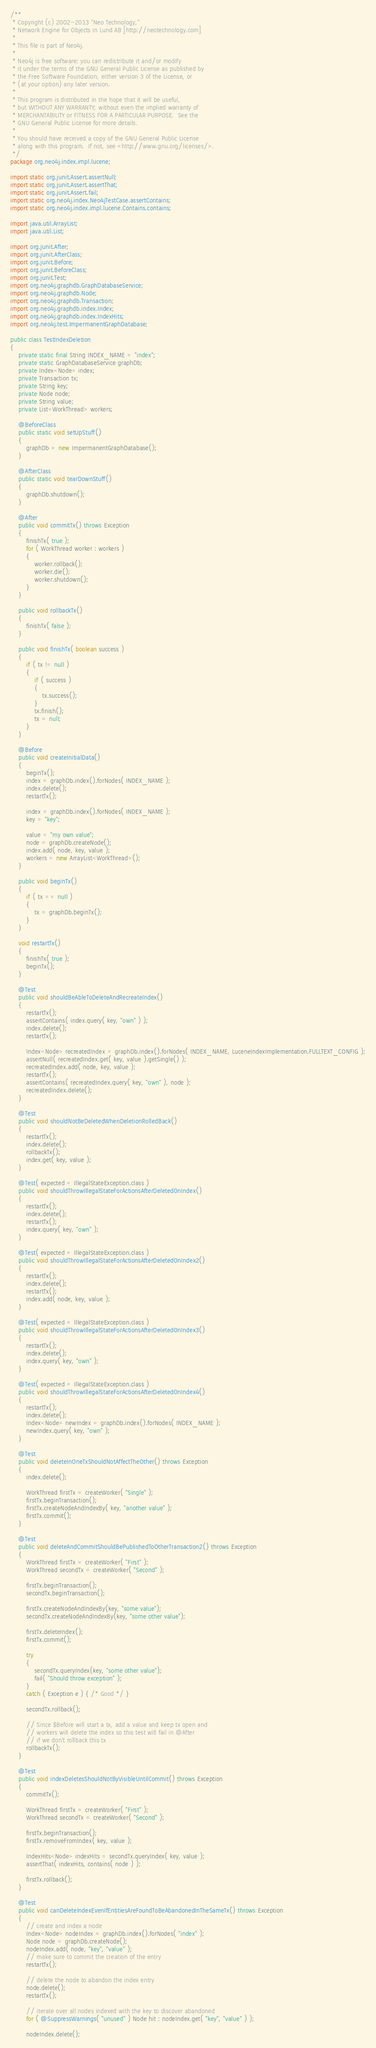<code> <loc_0><loc_0><loc_500><loc_500><_Java_>/**
 * Copyright (c) 2002-2013 "Neo Technology,"
 * Network Engine for Objects in Lund AB [http://neotechnology.com]
 *
 * This file is part of Neo4j.
 *
 * Neo4j is free software: you can redistribute it and/or modify
 * it under the terms of the GNU General Public License as published by
 * the Free Software Foundation, either version 3 of the License, or
 * (at your option) any later version.
 *
 * This program is distributed in the hope that it will be useful,
 * but WITHOUT ANY WARRANTY; without even the implied warranty of
 * MERCHANTABILITY or FITNESS FOR A PARTICULAR PURPOSE.  See the
 * GNU General Public License for more details.
 *
 * You should have received a copy of the GNU General Public License
 * along with this program.  If not, see <http://www.gnu.org/licenses/>.
 */
package org.neo4j.index.impl.lucene;

import static org.junit.Assert.assertNull;
import static org.junit.Assert.assertThat;
import static org.junit.Assert.fail;
import static org.neo4j.index.Neo4jTestCase.assertContains;
import static org.neo4j.index.impl.lucene.Contains.contains;

import java.util.ArrayList;
import java.util.List;

import org.junit.After;
import org.junit.AfterClass;
import org.junit.Before;
import org.junit.BeforeClass;
import org.junit.Test;
import org.neo4j.graphdb.GraphDatabaseService;
import org.neo4j.graphdb.Node;
import org.neo4j.graphdb.Transaction;
import org.neo4j.graphdb.index.Index;
import org.neo4j.graphdb.index.IndexHits;
import org.neo4j.test.ImpermanentGraphDatabase;

public class TestIndexDeletion
{
    private static final String INDEX_NAME = "index";
    private static GraphDatabaseService graphDb;
    private Index<Node> index;
    private Transaction tx;
    private String key;
    private Node node;
    private String value;
    private List<WorkThread> workers;

    @BeforeClass
    public static void setUpStuff()
    {
        graphDb = new ImpermanentGraphDatabase();
    }

    @AfterClass
    public static void tearDownStuff()
    {
        graphDb.shutdown();
    }

    @After
    public void commitTx() throws Exception
    {
        finishTx( true );
        for ( WorkThread worker : workers )
        {
            worker.rollback();
            worker.die();
            worker.shutdown();
        }
    }

    public void rollbackTx()
    {
        finishTx( false );
    }

    public void finishTx( boolean success )
    {
        if ( tx != null )
        {
            if ( success )
            {
                tx.success();
            }
            tx.finish();
            tx = null;
        }
    }

    @Before
    public void createInitialData()
    {
        beginTx();
        index = graphDb.index().forNodes( INDEX_NAME );
        index.delete();
        restartTx();

        index = graphDb.index().forNodes( INDEX_NAME );
        key = "key";

        value = "my own value";
        node = graphDb.createNode();
        index.add( node, key, value );
        workers = new ArrayList<WorkThread>();
    }

    public void beginTx()
    {
        if ( tx == null )
        {
            tx = graphDb.beginTx();
        }
    }

    void restartTx()
    {
        finishTx( true );
        beginTx();
    }

    @Test
    public void shouldBeAbleToDeleteAndRecreateIndex()
    {
        restartTx();
        assertContains( index.query( key, "own" ) );
        index.delete();
        restartTx();

        Index<Node> recreatedIndex = graphDb.index().forNodes( INDEX_NAME, LuceneIndexImplementation.FULLTEXT_CONFIG );
        assertNull( recreatedIndex.get( key, value ).getSingle() );
        recreatedIndex.add( node, key, value );
        restartTx();
        assertContains( recreatedIndex.query( key, "own" ), node );
        recreatedIndex.delete();
    }

    @Test
    public void shouldNotBeDeletedWhenDeletionRolledBack()
    {
        restartTx();
        index.delete();
        rollbackTx();
        index.get( key, value );
    }

    @Test( expected = IllegalStateException.class )
    public void shouldThrowIllegalStateForActionsAfterDeletedOnIndex()
    {
        restartTx();
        index.delete();
        restartTx();
        index.query( key, "own" );
    }

    @Test( expected = IllegalStateException.class )
    public void shouldThrowIllegalStateForActionsAfterDeletedOnIndex2()
    {
        restartTx();
        index.delete();
        restartTx();
        index.add( node, key, value );
    }

    @Test( expected = IllegalStateException.class )
    public void shouldThrowIllegalStateForActionsAfterDeletedOnIndex3()
    {
        restartTx();
        index.delete();
        index.query( key, "own" );
    }

    @Test( expected = IllegalStateException.class )
    public void shouldThrowIllegalStateForActionsAfterDeletedOnIndex4()
    {
        restartTx();
        index.delete();
        Index<Node> newIndex = graphDb.index().forNodes( INDEX_NAME );
        newIndex.query( key, "own" );
    }

    @Test
    public void deleteInOneTxShouldNotAffectTheOther() throws Exception
    {
        index.delete();

        WorkThread firstTx = createWorker( "Single" );
        firstTx.beginTransaction();
        firstTx.createNodeAndIndexBy( key, "another value" );
        firstTx.commit();
    }

	@Test
	public void deleteAndCommitShouldBePublishedToOtherTransaction2() throws Exception
	{
		WorkThread firstTx = createWorker( "First" );
		WorkThread secondTx = createWorker( "Second" );

		firstTx.beginTransaction();
		secondTx.beginTransaction();

		firstTx.createNodeAndIndexBy(key, "some value");
		secondTx.createNodeAndIndexBy(key, "some other value");

		firstTx.deleteIndex();
		firstTx.commit();

		try
        {
            secondTx.queryIndex(key, "some other value");
            fail( "Should throw exception" );
        }
        catch ( Exception e ) { /* Good */ }

		secondTx.rollback();

		// Since $Before will start a tx, add a value and keep tx open and
		// workers will delete the index so this test will fail in @After
		// if we don't rollback this tx
		rollbackTx();
	}

    @Test
    public void indexDeletesShouldNotByVisibleUntilCommit() throws Exception
    {
        commitTx();

        WorkThread firstTx = createWorker( "First" );
        WorkThread secondTx = createWorker( "Second" );

        firstTx.beginTransaction();
        firstTx.removeFromIndex( key, value );

        IndexHits<Node> indexHits = secondTx.queryIndex( key, value );
        assertThat( indexHits, contains( node ) );

        firstTx.rollback();
    }

    @Test
    public void canDeleteIndexEvenIfEntitiesAreFoundToBeAbandonedInTheSameTx() throws Exception
    {
        // create and index a node
        Index<Node> nodeIndex = graphDb.index().forNodes( "index" );
        Node node = graphDb.createNode();
        nodeIndex.add( node, "key", "value" );
        // make sure to commit the creation of the entry
        restartTx();

        // delete the node to abandon the index entry
        node.delete();
        restartTx();

        // iterate over all nodes indexed with the key to discover abandoned
        for ( @SuppressWarnings( "unused" ) Node hit : nodeIndex.get( "key", "value" ) );

        nodeIndex.delete();</code> 